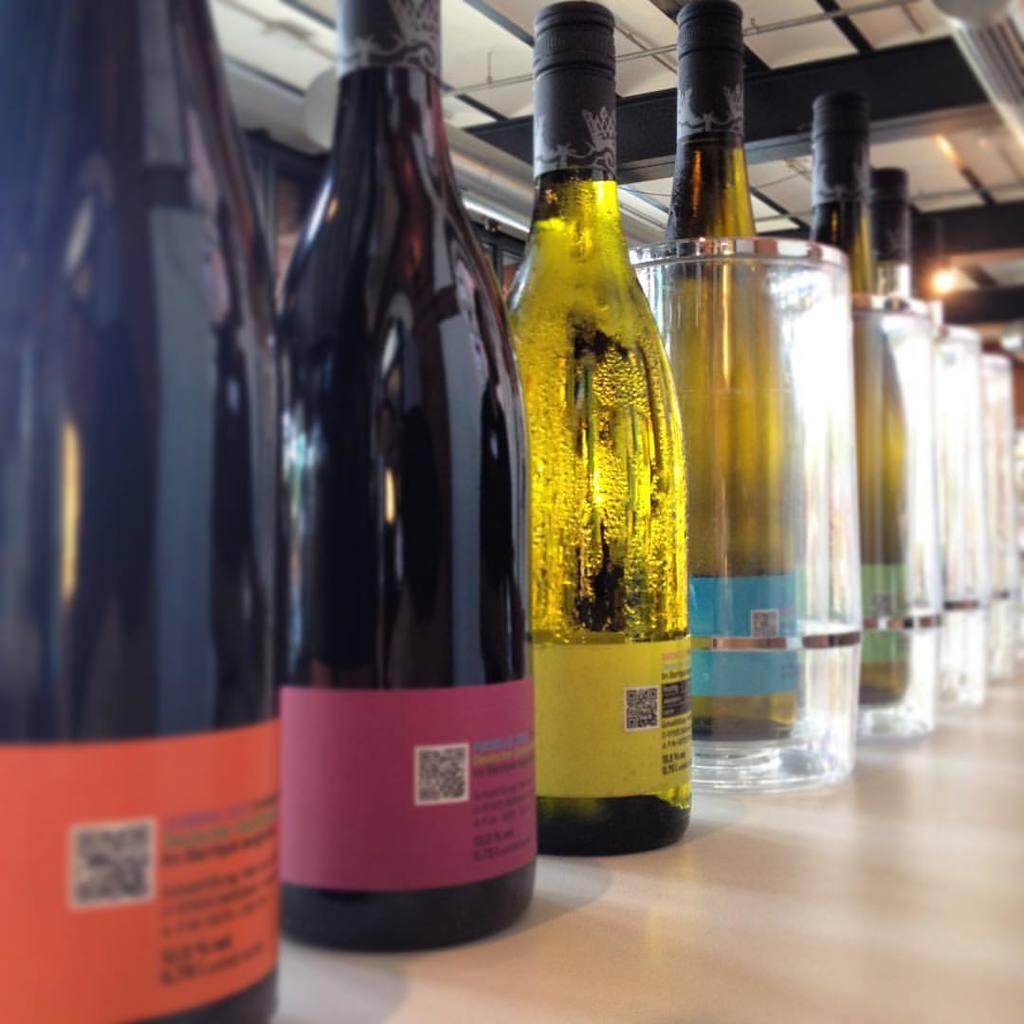Please provide a concise description of this image. This image consists of many bottles of alcohol are kept on a table. At the top, there is a roof. 